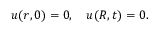Convert formula to latex. <formula><loc_0><loc_0><loc_500><loc_500>u ( r , 0 ) = 0 , \quad u ( R , t ) = 0 .</formula> 